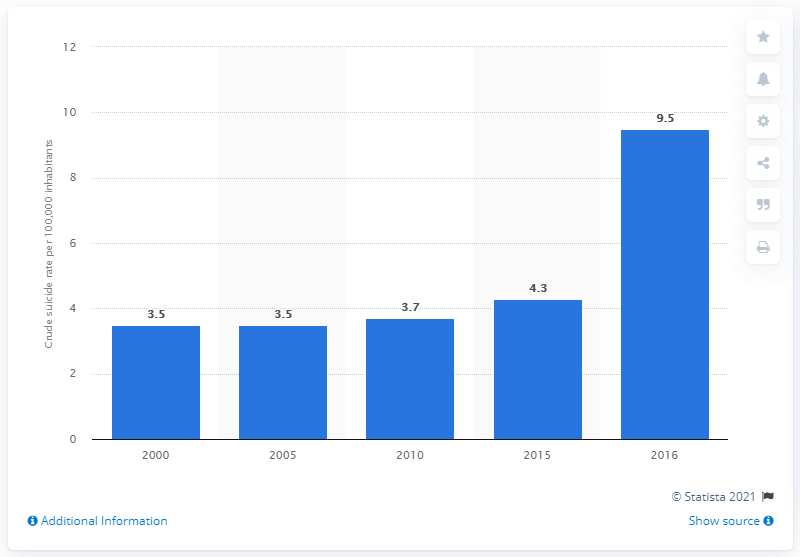Highlight a few significant elements in this photo. The number of suicides per 100,000 of the population in 2005 was 3.5. In 2016, the suicide rate in Burma was 9.5 per 100,000 people. 